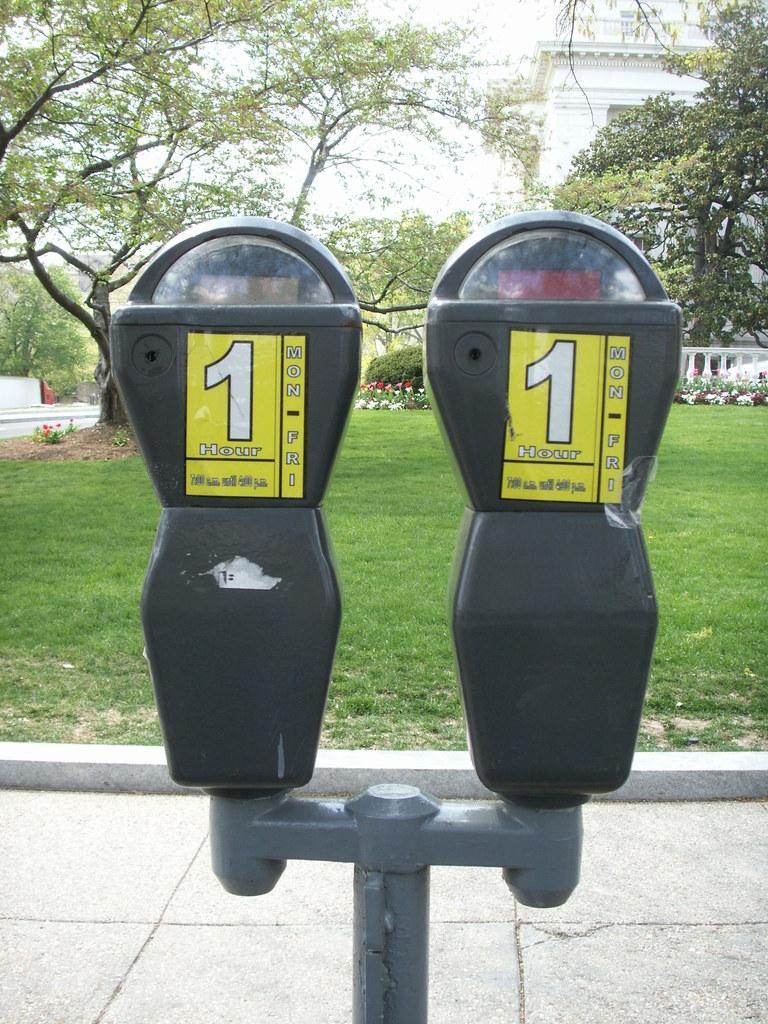How would you summarize this image in a sentence or two? This picture shows a building and few trees and we see a parking machine on the sidewalk and we see grass on the ground. 